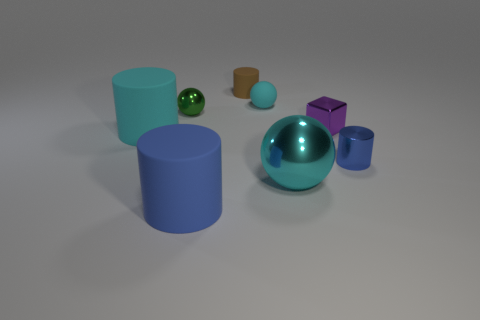Are there any tiny metal things of the same color as the small metal sphere?
Keep it short and to the point. No. Is there a tiny red rubber thing?
Offer a terse response. No. What is the shape of the blue object in front of the big cyan sphere?
Offer a very short reply. Cylinder. How many cylinders are on the right side of the cyan metal sphere and left of the cube?
Offer a very short reply. 0. How many other objects are the same size as the purple block?
Keep it short and to the point. 4. Is the shape of the small metallic object behind the tiny purple metal object the same as the large rubber object that is in front of the blue metallic cylinder?
Provide a succinct answer. No. What number of objects are either small blue objects or small objects left of the tiny shiny cube?
Offer a terse response. 4. The object that is both behind the shiny block and left of the blue matte cylinder is made of what material?
Offer a terse response. Metal. Is there anything else that has the same shape as the brown object?
Ensure brevity in your answer.  Yes. What color is the cylinder that is made of the same material as the block?
Your answer should be compact. Blue. 